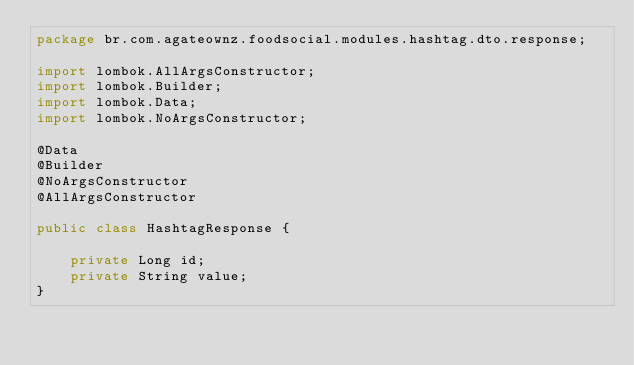Convert code to text. <code><loc_0><loc_0><loc_500><loc_500><_Java_>package br.com.agateownz.foodsocial.modules.hashtag.dto.response;

import lombok.AllArgsConstructor;
import lombok.Builder;
import lombok.Data;
import lombok.NoArgsConstructor;

@Data
@Builder
@NoArgsConstructor
@AllArgsConstructor

public class HashtagResponse {

    private Long id;
    private String value;
}
</code> 